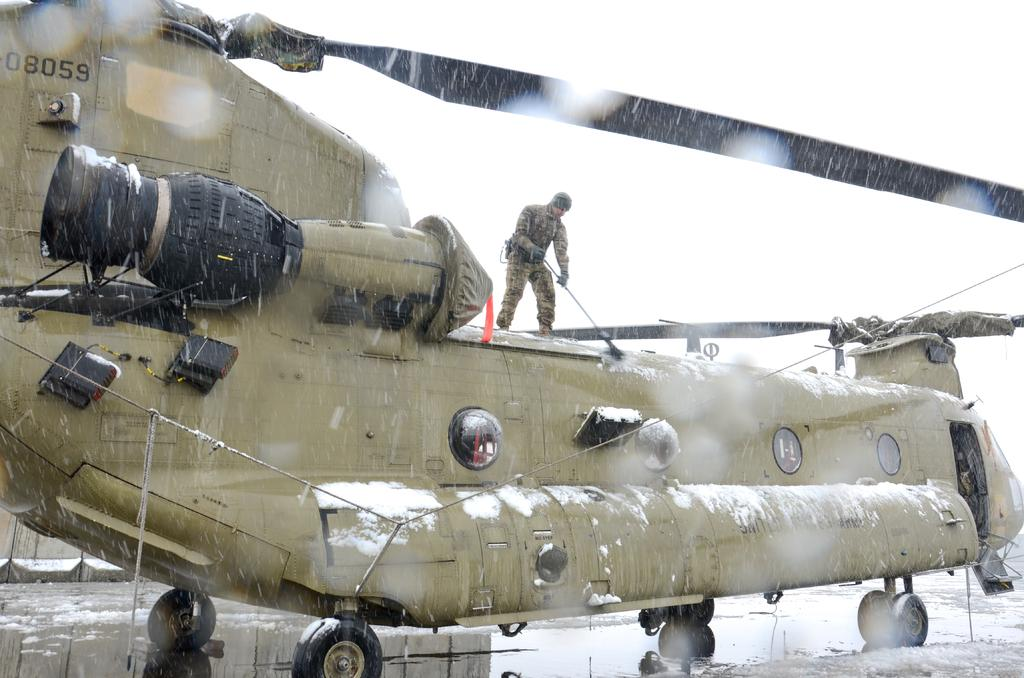<image>
Summarize the visual content of the image. The numbers on the top of the helicopter read 08059. 